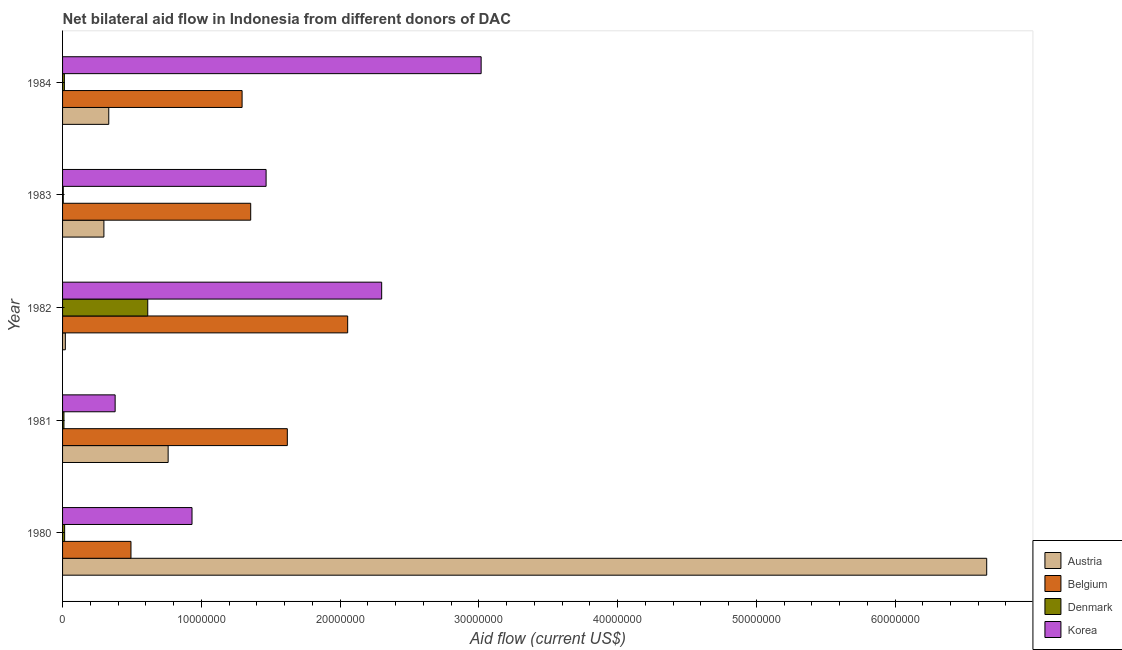How many different coloured bars are there?
Offer a very short reply. 4. Are the number of bars per tick equal to the number of legend labels?
Your response must be concise. Yes. How many bars are there on the 3rd tick from the top?
Give a very brief answer. 4. How many bars are there on the 4th tick from the bottom?
Ensure brevity in your answer.  4. What is the label of the 4th group of bars from the top?
Ensure brevity in your answer.  1981. What is the amount of aid given by korea in 1982?
Your response must be concise. 2.30e+07. Across all years, what is the maximum amount of aid given by belgium?
Your response must be concise. 2.06e+07. Across all years, what is the minimum amount of aid given by austria?
Give a very brief answer. 2.00e+05. In which year was the amount of aid given by belgium maximum?
Your answer should be very brief. 1982. In which year was the amount of aid given by belgium minimum?
Offer a terse response. 1980. What is the total amount of aid given by denmark in the graph?
Offer a terse response. 6.57e+06. What is the difference between the amount of aid given by austria in 1982 and that in 1983?
Your response must be concise. -2.78e+06. What is the difference between the amount of aid given by korea in 1982 and the amount of aid given by denmark in 1981?
Your answer should be compact. 2.29e+07. What is the average amount of aid given by austria per year?
Give a very brief answer. 1.61e+07. In the year 1984, what is the difference between the amount of aid given by austria and amount of aid given by belgium?
Provide a short and direct response. -9.61e+06. In how many years, is the amount of aid given by belgium greater than 38000000 US$?
Provide a succinct answer. 0. What is the ratio of the amount of aid given by korea in 1983 to that in 1984?
Your answer should be very brief. 0.49. Is the amount of aid given by austria in 1982 less than that in 1983?
Your answer should be very brief. Yes. What is the difference between the highest and the second highest amount of aid given by denmark?
Your answer should be compact. 5.99e+06. What is the difference between the highest and the lowest amount of aid given by austria?
Make the answer very short. 6.64e+07. In how many years, is the amount of aid given by austria greater than the average amount of aid given by austria taken over all years?
Your answer should be compact. 1. What does the 2nd bar from the top in 1984 represents?
Provide a short and direct response. Denmark. How many bars are there?
Your answer should be compact. 20. How many years are there in the graph?
Provide a succinct answer. 5. Are the values on the major ticks of X-axis written in scientific E-notation?
Keep it short and to the point. No. Does the graph contain any zero values?
Offer a very short reply. No. Does the graph contain grids?
Your response must be concise. No. Where does the legend appear in the graph?
Keep it short and to the point. Bottom right. How many legend labels are there?
Provide a succinct answer. 4. How are the legend labels stacked?
Offer a very short reply. Vertical. What is the title of the graph?
Offer a terse response. Net bilateral aid flow in Indonesia from different donors of DAC. What is the label or title of the Y-axis?
Your answer should be very brief. Year. What is the Aid flow (current US$) of Austria in 1980?
Provide a succinct answer. 6.66e+07. What is the Aid flow (current US$) in Belgium in 1980?
Your response must be concise. 4.93e+06. What is the Aid flow (current US$) in Denmark in 1980?
Keep it short and to the point. 1.50e+05. What is the Aid flow (current US$) in Korea in 1980?
Your answer should be very brief. 9.33e+06. What is the Aid flow (current US$) of Austria in 1981?
Provide a short and direct response. 7.61e+06. What is the Aid flow (current US$) in Belgium in 1981?
Your response must be concise. 1.62e+07. What is the Aid flow (current US$) of Denmark in 1981?
Give a very brief answer. 1.00e+05. What is the Aid flow (current US$) of Korea in 1981?
Provide a succinct answer. 3.79e+06. What is the Aid flow (current US$) of Belgium in 1982?
Ensure brevity in your answer.  2.06e+07. What is the Aid flow (current US$) in Denmark in 1982?
Give a very brief answer. 6.14e+06. What is the Aid flow (current US$) of Korea in 1982?
Your answer should be compact. 2.30e+07. What is the Aid flow (current US$) in Austria in 1983?
Offer a terse response. 2.98e+06. What is the Aid flow (current US$) of Belgium in 1983?
Give a very brief answer. 1.36e+07. What is the Aid flow (current US$) of Denmark in 1983?
Offer a terse response. 5.00e+04. What is the Aid flow (current US$) of Korea in 1983?
Provide a succinct answer. 1.47e+07. What is the Aid flow (current US$) in Austria in 1984?
Keep it short and to the point. 3.33e+06. What is the Aid flow (current US$) of Belgium in 1984?
Your answer should be very brief. 1.29e+07. What is the Aid flow (current US$) of Korea in 1984?
Give a very brief answer. 3.02e+07. Across all years, what is the maximum Aid flow (current US$) in Austria?
Your response must be concise. 6.66e+07. Across all years, what is the maximum Aid flow (current US$) in Belgium?
Ensure brevity in your answer.  2.06e+07. Across all years, what is the maximum Aid flow (current US$) of Denmark?
Provide a succinct answer. 6.14e+06. Across all years, what is the maximum Aid flow (current US$) of Korea?
Offer a very short reply. 3.02e+07. Across all years, what is the minimum Aid flow (current US$) in Austria?
Your answer should be compact. 2.00e+05. Across all years, what is the minimum Aid flow (current US$) of Belgium?
Offer a very short reply. 4.93e+06. Across all years, what is the minimum Aid flow (current US$) in Denmark?
Offer a terse response. 5.00e+04. Across all years, what is the minimum Aid flow (current US$) in Korea?
Keep it short and to the point. 3.79e+06. What is the total Aid flow (current US$) of Austria in the graph?
Give a very brief answer. 8.07e+07. What is the total Aid flow (current US$) of Belgium in the graph?
Provide a succinct answer. 6.82e+07. What is the total Aid flow (current US$) in Denmark in the graph?
Provide a succinct answer. 6.57e+06. What is the total Aid flow (current US$) of Korea in the graph?
Keep it short and to the point. 8.10e+07. What is the difference between the Aid flow (current US$) of Austria in 1980 and that in 1981?
Keep it short and to the point. 5.90e+07. What is the difference between the Aid flow (current US$) in Belgium in 1980 and that in 1981?
Provide a succinct answer. -1.13e+07. What is the difference between the Aid flow (current US$) in Korea in 1980 and that in 1981?
Give a very brief answer. 5.54e+06. What is the difference between the Aid flow (current US$) of Austria in 1980 and that in 1982?
Make the answer very short. 6.64e+07. What is the difference between the Aid flow (current US$) in Belgium in 1980 and that in 1982?
Offer a terse response. -1.56e+07. What is the difference between the Aid flow (current US$) in Denmark in 1980 and that in 1982?
Provide a succinct answer. -5.99e+06. What is the difference between the Aid flow (current US$) of Korea in 1980 and that in 1982?
Offer a terse response. -1.37e+07. What is the difference between the Aid flow (current US$) of Austria in 1980 and that in 1983?
Give a very brief answer. 6.36e+07. What is the difference between the Aid flow (current US$) in Belgium in 1980 and that in 1983?
Give a very brief answer. -8.63e+06. What is the difference between the Aid flow (current US$) of Denmark in 1980 and that in 1983?
Your answer should be compact. 1.00e+05. What is the difference between the Aid flow (current US$) of Korea in 1980 and that in 1983?
Provide a short and direct response. -5.34e+06. What is the difference between the Aid flow (current US$) of Austria in 1980 and that in 1984?
Give a very brief answer. 6.33e+07. What is the difference between the Aid flow (current US$) in Belgium in 1980 and that in 1984?
Your response must be concise. -8.01e+06. What is the difference between the Aid flow (current US$) of Korea in 1980 and that in 1984?
Ensure brevity in your answer.  -2.08e+07. What is the difference between the Aid flow (current US$) of Austria in 1981 and that in 1982?
Provide a succinct answer. 7.41e+06. What is the difference between the Aid flow (current US$) of Belgium in 1981 and that in 1982?
Provide a short and direct response. -4.35e+06. What is the difference between the Aid flow (current US$) in Denmark in 1981 and that in 1982?
Make the answer very short. -6.04e+06. What is the difference between the Aid flow (current US$) in Korea in 1981 and that in 1982?
Offer a terse response. -1.92e+07. What is the difference between the Aid flow (current US$) of Austria in 1981 and that in 1983?
Make the answer very short. 4.63e+06. What is the difference between the Aid flow (current US$) in Belgium in 1981 and that in 1983?
Your answer should be compact. 2.64e+06. What is the difference between the Aid flow (current US$) in Korea in 1981 and that in 1983?
Your answer should be very brief. -1.09e+07. What is the difference between the Aid flow (current US$) in Austria in 1981 and that in 1984?
Your answer should be compact. 4.28e+06. What is the difference between the Aid flow (current US$) of Belgium in 1981 and that in 1984?
Offer a terse response. 3.26e+06. What is the difference between the Aid flow (current US$) of Denmark in 1981 and that in 1984?
Your answer should be compact. -3.00e+04. What is the difference between the Aid flow (current US$) of Korea in 1981 and that in 1984?
Your answer should be compact. -2.64e+07. What is the difference between the Aid flow (current US$) in Austria in 1982 and that in 1983?
Your answer should be very brief. -2.78e+06. What is the difference between the Aid flow (current US$) in Belgium in 1982 and that in 1983?
Your response must be concise. 6.99e+06. What is the difference between the Aid flow (current US$) in Denmark in 1982 and that in 1983?
Your response must be concise. 6.09e+06. What is the difference between the Aid flow (current US$) of Korea in 1982 and that in 1983?
Your answer should be compact. 8.33e+06. What is the difference between the Aid flow (current US$) of Austria in 1982 and that in 1984?
Offer a terse response. -3.13e+06. What is the difference between the Aid flow (current US$) in Belgium in 1982 and that in 1984?
Provide a succinct answer. 7.61e+06. What is the difference between the Aid flow (current US$) of Denmark in 1982 and that in 1984?
Ensure brevity in your answer.  6.01e+06. What is the difference between the Aid flow (current US$) in Korea in 1982 and that in 1984?
Offer a terse response. -7.17e+06. What is the difference between the Aid flow (current US$) in Austria in 1983 and that in 1984?
Offer a terse response. -3.50e+05. What is the difference between the Aid flow (current US$) in Belgium in 1983 and that in 1984?
Your response must be concise. 6.20e+05. What is the difference between the Aid flow (current US$) in Korea in 1983 and that in 1984?
Offer a terse response. -1.55e+07. What is the difference between the Aid flow (current US$) of Austria in 1980 and the Aid flow (current US$) of Belgium in 1981?
Provide a succinct answer. 5.04e+07. What is the difference between the Aid flow (current US$) in Austria in 1980 and the Aid flow (current US$) in Denmark in 1981?
Provide a short and direct response. 6.65e+07. What is the difference between the Aid flow (current US$) in Austria in 1980 and the Aid flow (current US$) in Korea in 1981?
Give a very brief answer. 6.28e+07. What is the difference between the Aid flow (current US$) in Belgium in 1980 and the Aid flow (current US$) in Denmark in 1981?
Give a very brief answer. 4.83e+06. What is the difference between the Aid flow (current US$) of Belgium in 1980 and the Aid flow (current US$) of Korea in 1981?
Provide a short and direct response. 1.14e+06. What is the difference between the Aid flow (current US$) of Denmark in 1980 and the Aid flow (current US$) of Korea in 1981?
Offer a very short reply. -3.64e+06. What is the difference between the Aid flow (current US$) in Austria in 1980 and the Aid flow (current US$) in Belgium in 1982?
Provide a succinct answer. 4.61e+07. What is the difference between the Aid flow (current US$) of Austria in 1980 and the Aid flow (current US$) of Denmark in 1982?
Ensure brevity in your answer.  6.05e+07. What is the difference between the Aid flow (current US$) in Austria in 1980 and the Aid flow (current US$) in Korea in 1982?
Give a very brief answer. 4.36e+07. What is the difference between the Aid flow (current US$) in Belgium in 1980 and the Aid flow (current US$) in Denmark in 1982?
Make the answer very short. -1.21e+06. What is the difference between the Aid flow (current US$) in Belgium in 1980 and the Aid flow (current US$) in Korea in 1982?
Your answer should be compact. -1.81e+07. What is the difference between the Aid flow (current US$) in Denmark in 1980 and the Aid flow (current US$) in Korea in 1982?
Provide a short and direct response. -2.28e+07. What is the difference between the Aid flow (current US$) of Austria in 1980 and the Aid flow (current US$) of Belgium in 1983?
Your answer should be compact. 5.30e+07. What is the difference between the Aid flow (current US$) in Austria in 1980 and the Aid flow (current US$) in Denmark in 1983?
Ensure brevity in your answer.  6.66e+07. What is the difference between the Aid flow (current US$) of Austria in 1980 and the Aid flow (current US$) of Korea in 1983?
Provide a short and direct response. 5.19e+07. What is the difference between the Aid flow (current US$) of Belgium in 1980 and the Aid flow (current US$) of Denmark in 1983?
Provide a succinct answer. 4.88e+06. What is the difference between the Aid flow (current US$) of Belgium in 1980 and the Aid flow (current US$) of Korea in 1983?
Provide a short and direct response. -9.74e+06. What is the difference between the Aid flow (current US$) of Denmark in 1980 and the Aid flow (current US$) of Korea in 1983?
Keep it short and to the point. -1.45e+07. What is the difference between the Aid flow (current US$) of Austria in 1980 and the Aid flow (current US$) of Belgium in 1984?
Provide a short and direct response. 5.37e+07. What is the difference between the Aid flow (current US$) in Austria in 1980 and the Aid flow (current US$) in Denmark in 1984?
Provide a succinct answer. 6.65e+07. What is the difference between the Aid flow (current US$) in Austria in 1980 and the Aid flow (current US$) in Korea in 1984?
Offer a terse response. 3.64e+07. What is the difference between the Aid flow (current US$) of Belgium in 1980 and the Aid flow (current US$) of Denmark in 1984?
Keep it short and to the point. 4.80e+06. What is the difference between the Aid flow (current US$) in Belgium in 1980 and the Aid flow (current US$) in Korea in 1984?
Your response must be concise. -2.52e+07. What is the difference between the Aid flow (current US$) of Denmark in 1980 and the Aid flow (current US$) of Korea in 1984?
Your answer should be very brief. -3.00e+07. What is the difference between the Aid flow (current US$) of Austria in 1981 and the Aid flow (current US$) of Belgium in 1982?
Your answer should be very brief. -1.29e+07. What is the difference between the Aid flow (current US$) of Austria in 1981 and the Aid flow (current US$) of Denmark in 1982?
Give a very brief answer. 1.47e+06. What is the difference between the Aid flow (current US$) in Austria in 1981 and the Aid flow (current US$) in Korea in 1982?
Ensure brevity in your answer.  -1.54e+07. What is the difference between the Aid flow (current US$) in Belgium in 1981 and the Aid flow (current US$) in Denmark in 1982?
Provide a succinct answer. 1.01e+07. What is the difference between the Aid flow (current US$) of Belgium in 1981 and the Aid flow (current US$) of Korea in 1982?
Provide a short and direct response. -6.80e+06. What is the difference between the Aid flow (current US$) in Denmark in 1981 and the Aid flow (current US$) in Korea in 1982?
Offer a very short reply. -2.29e+07. What is the difference between the Aid flow (current US$) of Austria in 1981 and the Aid flow (current US$) of Belgium in 1983?
Provide a succinct answer. -5.95e+06. What is the difference between the Aid flow (current US$) in Austria in 1981 and the Aid flow (current US$) in Denmark in 1983?
Make the answer very short. 7.56e+06. What is the difference between the Aid flow (current US$) of Austria in 1981 and the Aid flow (current US$) of Korea in 1983?
Offer a terse response. -7.06e+06. What is the difference between the Aid flow (current US$) of Belgium in 1981 and the Aid flow (current US$) of Denmark in 1983?
Keep it short and to the point. 1.62e+07. What is the difference between the Aid flow (current US$) in Belgium in 1981 and the Aid flow (current US$) in Korea in 1983?
Keep it short and to the point. 1.53e+06. What is the difference between the Aid flow (current US$) of Denmark in 1981 and the Aid flow (current US$) of Korea in 1983?
Keep it short and to the point. -1.46e+07. What is the difference between the Aid flow (current US$) in Austria in 1981 and the Aid flow (current US$) in Belgium in 1984?
Provide a succinct answer. -5.33e+06. What is the difference between the Aid flow (current US$) of Austria in 1981 and the Aid flow (current US$) of Denmark in 1984?
Your answer should be very brief. 7.48e+06. What is the difference between the Aid flow (current US$) of Austria in 1981 and the Aid flow (current US$) of Korea in 1984?
Your answer should be compact. -2.26e+07. What is the difference between the Aid flow (current US$) of Belgium in 1981 and the Aid flow (current US$) of Denmark in 1984?
Make the answer very short. 1.61e+07. What is the difference between the Aid flow (current US$) of Belgium in 1981 and the Aid flow (current US$) of Korea in 1984?
Your answer should be very brief. -1.40e+07. What is the difference between the Aid flow (current US$) of Denmark in 1981 and the Aid flow (current US$) of Korea in 1984?
Your answer should be very brief. -3.01e+07. What is the difference between the Aid flow (current US$) of Austria in 1982 and the Aid flow (current US$) of Belgium in 1983?
Provide a succinct answer. -1.34e+07. What is the difference between the Aid flow (current US$) of Austria in 1982 and the Aid flow (current US$) of Denmark in 1983?
Make the answer very short. 1.50e+05. What is the difference between the Aid flow (current US$) in Austria in 1982 and the Aid flow (current US$) in Korea in 1983?
Your answer should be compact. -1.45e+07. What is the difference between the Aid flow (current US$) of Belgium in 1982 and the Aid flow (current US$) of Denmark in 1983?
Your answer should be very brief. 2.05e+07. What is the difference between the Aid flow (current US$) of Belgium in 1982 and the Aid flow (current US$) of Korea in 1983?
Your response must be concise. 5.88e+06. What is the difference between the Aid flow (current US$) of Denmark in 1982 and the Aid flow (current US$) of Korea in 1983?
Offer a very short reply. -8.53e+06. What is the difference between the Aid flow (current US$) of Austria in 1982 and the Aid flow (current US$) of Belgium in 1984?
Your answer should be compact. -1.27e+07. What is the difference between the Aid flow (current US$) of Austria in 1982 and the Aid flow (current US$) of Korea in 1984?
Give a very brief answer. -3.00e+07. What is the difference between the Aid flow (current US$) in Belgium in 1982 and the Aid flow (current US$) in Denmark in 1984?
Provide a succinct answer. 2.04e+07. What is the difference between the Aid flow (current US$) in Belgium in 1982 and the Aid flow (current US$) in Korea in 1984?
Your response must be concise. -9.62e+06. What is the difference between the Aid flow (current US$) of Denmark in 1982 and the Aid flow (current US$) of Korea in 1984?
Keep it short and to the point. -2.40e+07. What is the difference between the Aid flow (current US$) of Austria in 1983 and the Aid flow (current US$) of Belgium in 1984?
Keep it short and to the point. -9.96e+06. What is the difference between the Aid flow (current US$) of Austria in 1983 and the Aid flow (current US$) of Denmark in 1984?
Make the answer very short. 2.85e+06. What is the difference between the Aid flow (current US$) in Austria in 1983 and the Aid flow (current US$) in Korea in 1984?
Your response must be concise. -2.72e+07. What is the difference between the Aid flow (current US$) in Belgium in 1983 and the Aid flow (current US$) in Denmark in 1984?
Your answer should be very brief. 1.34e+07. What is the difference between the Aid flow (current US$) of Belgium in 1983 and the Aid flow (current US$) of Korea in 1984?
Provide a succinct answer. -1.66e+07. What is the difference between the Aid flow (current US$) of Denmark in 1983 and the Aid flow (current US$) of Korea in 1984?
Provide a short and direct response. -3.01e+07. What is the average Aid flow (current US$) of Austria per year?
Your response must be concise. 1.61e+07. What is the average Aid flow (current US$) of Belgium per year?
Your answer should be compact. 1.36e+07. What is the average Aid flow (current US$) of Denmark per year?
Provide a short and direct response. 1.31e+06. What is the average Aid flow (current US$) in Korea per year?
Provide a short and direct response. 1.62e+07. In the year 1980, what is the difference between the Aid flow (current US$) of Austria and Aid flow (current US$) of Belgium?
Provide a short and direct response. 6.17e+07. In the year 1980, what is the difference between the Aid flow (current US$) in Austria and Aid flow (current US$) in Denmark?
Provide a succinct answer. 6.65e+07. In the year 1980, what is the difference between the Aid flow (current US$) of Austria and Aid flow (current US$) of Korea?
Your response must be concise. 5.73e+07. In the year 1980, what is the difference between the Aid flow (current US$) in Belgium and Aid flow (current US$) in Denmark?
Your response must be concise. 4.78e+06. In the year 1980, what is the difference between the Aid flow (current US$) of Belgium and Aid flow (current US$) of Korea?
Your response must be concise. -4.40e+06. In the year 1980, what is the difference between the Aid flow (current US$) of Denmark and Aid flow (current US$) of Korea?
Give a very brief answer. -9.18e+06. In the year 1981, what is the difference between the Aid flow (current US$) of Austria and Aid flow (current US$) of Belgium?
Provide a succinct answer. -8.59e+06. In the year 1981, what is the difference between the Aid flow (current US$) of Austria and Aid flow (current US$) of Denmark?
Make the answer very short. 7.51e+06. In the year 1981, what is the difference between the Aid flow (current US$) in Austria and Aid flow (current US$) in Korea?
Provide a succinct answer. 3.82e+06. In the year 1981, what is the difference between the Aid flow (current US$) of Belgium and Aid flow (current US$) of Denmark?
Make the answer very short. 1.61e+07. In the year 1981, what is the difference between the Aid flow (current US$) of Belgium and Aid flow (current US$) of Korea?
Ensure brevity in your answer.  1.24e+07. In the year 1981, what is the difference between the Aid flow (current US$) of Denmark and Aid flow (current US$) of Korea?
Your answer should be compact. -3.69e+06. In the year 1982, what is the difference between the Aid flow (current US$) in Austria and Aid flow (current US$) in Belgium?
Keep it short and to the point. -2.04e+07. In the year 1982, what is the difference between the Aid flow (current US$) in Austria and Aid flow (current US$) in Denmark?
Offer a terse response. -5.94e+06. In the year 1982, what is the difference between the Aid flow (current US$) of Austria and Aid flow (current US$) of Korea?
Offer a very short reply. -2.28e+07. In the year 1982, what is the difference between the Aid flow (current US$) of Belgium and Aid flow (current US$) of Denmark?
Keep it short and to the point. 1.44e+07. In the year 1982, what is the difference between the Aid flow (current US$) of Belgium and Aid flow (current US$) of Korea?
Your answer should be compact. -2.45e+06. In the year 1982, what is the difference between the Aid flow (current US$) in Denmark and Aid flow (current US$) in Korea?
Keep it short and to the point. -1.69e+07. In the year 1983, what is the difference between the Aid flow (current US$) in Austria and Aid flow (current US$) in Belgium?
Provide a short and direct response. -1.06e+07. In the year 1983, what is the difference between the Aid flow (current US$) in Austria and Aid flow (current US$) in Denmark?
Ensure brevity in your answer.  2.93e+06. In the year 1983, what is the difference between the Aid flow (current US$) in Austria and Aid flow (current US$) in Korea?
Your answer should be very brief. -1.17e+07. In the year 1983, what is the difference between the Aid flow (current US$) of Belgium and Aid flow (current US$) of Denmark?
Offer a very short reply. 1.35e+07. In the year 1983, what is the difference between the Aid flow (current US$) of Belgium and Aid flow (current US$) of Korea?
Make the answer very short. -1.11e+06. In the year 1983, what is the difference between the Aid flow (current US$) in Denmark and Aid flow (current US$) in Korea?
Make the answer very short. -1.46e+07. In the year 1984, what is the difference between the Aid flow (current US$) of Austria and Aid flow (current US$) of Belgium?
Your answer should be very brief. -9.61e+06. In the year 1984, what is the difference between the Aid flow (current US$) in Austria and Aid flow (current US$) in Denmark?
Provide a succinct answer. 3.20e+06. In the year 1984, what is the difference between the Aid flow (current US$) of Austria and Aid flow (current US$) of Korea?
Offer a very short reply. -2.68e+07. In the year 1984, what is the difference between the Aid flow (current US$) in Belgium and Aid flow (current US$) in Denmark?
Give a very brief answer. 1.28e+07. In the year 1984, what is the difference between the Aid flow (current US$) of Belgium and Aid flow (current US$) of Korea?
Your answer should be compact. -1.72e+07. In the year 1984, what is the difference between the Aid flow (current US$) of Denmark and Aid flow (current US$) of Korea?
Ensure brevity in your answer.  -3.00e+07. What is the ratio of the Aid flow (current US$) in Austria in 1980 to that in 1981?
Give a very brief answer. 8.75. What is the ratio of the Aid flow (current US$) in Belgium in 1980 to that in 1981?
Your answer should be compact. 0.3. What is the ratio of the Aid flow (current US$) in Korea in 1980 to that in 1981?
Keep it short and to the point. 2.46. What is the ratio of the Aid flow (current US$) of Austria in 1980 to that in 1982?
Make the answer very short. 333.05. What is the ratio of the Aid flow (current US$) in Belgium in 1980 to that in 1982?
Your answer should be very brief. 0.24. What is the ratio of the Aid flow (current US$) in Denmark in 1980 to that in 1982?
Your response must be concise. 0.02. What is the ratio of the Aid flow (current US$) of Korea in 1980 to that in 1982?
Your response must be concise. 0.41. What is the ratio of the Aid flow (current US$) of Austria in 1980 to that in 1983?
Give a very brief answer. 22.35. What is the ratio of the Aid flow (current US$) of Belgium in 1980 to that in 1983?
Make the answer very short. 0.36. What is the ratio of the Aid flow (current US$) in Korea in 1980 to that in 1983?
Your response must be concise. 0.64. What is the ratio of the Aid flow (current US$) in Austria in 1980 to that in 1984?
Keep it short and to the point. 20. What is the ratio of the Aid flow (current US$) in Belgium in 1980 to that in 1984?
Offer a very short reply. 0.38. What is the ratio of the Aid flow (current US$) in Denmark in 1980 to that in 1984?
Your response must be concise. 1.15. What is the ratio of the Aid flow (current US$) in Korea in 1980 to that in 1984?
Provide a succinct answer. 0.31. What is the ratio of the Aid flow (current US$) of Austria in 1981 to that in 1982?
Your response must be concise. 38.05. What is the ratio of the Aid flow (current US$) in Belgium in 1981 to that in 1982?
Your answer should be very brief. 0.79. What is the ratio of the Aid flow (current US$) of Denmark in 1981 to that in 1982?
Your response must be concise. 0.02. What is the ratio of the Aid flow (current US$) in Korea in 1981 to that in 1982?
Your answer should be very brief. 0.16. What is the ratio of the Aid flow (current US$) of Austria in 1981 to that in 1983?
Offer a terse response. 2.55. What is the ratio of the Aid flow (current US$) of Belgium in 1981 to that in 1983?
Ensure brevity in your answer.  1.19. What is the ratio of the Aid flow (current US$) in Korea in 1981 to that in 1983?
Your response must be concise. 0.26. What is the ratio of the Aid flow (current US$) of Austria in 1981 to that in 1984?
Provide a short and direct response. 2.29. What is the ratio of the Aid flow (current US$) of Belgium in 1981 to that in 1984?
Your answer should be compact. 1.25. What is the ratio of the Aid flow (current US$) in Denmark in 1981 to that in 1984?
Give a very brief answer. 0.77. What is the ratio of the Aid flow (current US$) of Korea in 1981 to that in 1984?
Your answer should be very brief. 0.13. What is the ratio of the Aid flow (current US$) of Austria in 1982 to that in 1983?
Give a very brief answer. 0.07. What is the ratio of the Aid flow (current US$) of Belgium in 1982 to that in 1983?
Keep it short and to the point. 1.52. What is the ratio of the Aid flow (current US$) of Denmark in 1982 to that in 1983?
Give a very brief answer. 122.8. What is the ratio of the Aid flow (current US$) of Korea in 1982 to that in 1983?
Give a very brief answer. 1.57. What is the ratio of the Aid flow (current US$) of Austria in 1982 to that in 1984?
Offer a very short reply. 0.06. What is the ratio of the Aid flow (current US$) of Belgium in 1982 to that in 1984?
Provide a short and direct response. 1.59. What is the ratio of the Aid flow (current US$) in Denmark in 1982 to that in 1984?
Your answer should be compact. 47.23. What is the ratio of the Aid flow (current US$) of Korea in 1982 to that in 1984?
Make the answer very short. 0.76. What is the ratio of the Aid flow (current US$) in Austria in 1983 to that in 1984?
Your response must be concise. 0.89. What is the ratio of the Aid flow (current US$) of Belgium in 1983 to that in 1984?
Give a very brief answer. 1.05. What is the ratio of the Aid flow (current US$) in Denmark in 1983 to that in 1984?
Make the answer very short. 0.38. What is the ratio of the Aid flow (current US$) in Korea in 1983 to that in 1984?
Make the answer very short. 0.49. What is the difference between the highest and the second highest Aid flow (current US$) of Austria?
Give a very brief answer. 5.90e+07. What is the difference between the highest and the second highest Aid flow (current US$) in Belgium?
Offer a very short reply. 4.35e+06. What is the difference between the highest and the second highest Aid flow (current US$) in Denmark?
Ensure brevity in your answer.  5.99e+06. What is the difference between the highest and the second highest Aid flow (current US$) in Korea?
Your answer should be compact. 7.17e+06. What is the difference between the highest and the lowest Aid flow (current US$) of Austria?
Offer a very short reply. 6.64e+07. What is the difference between the highest and the lowest Aid flow (current US$) of Belgium?
Provide a succinct answer. 1.56e+07. What is the difference between the highest and the lowest Aid flow (current US$) in Denmark?
Your response must be concise. 6.09e+06. What is the difference between the highest and the lowest Aid flow (current US$) of Korea?
Offer a very short reply. 2.64e+07. 